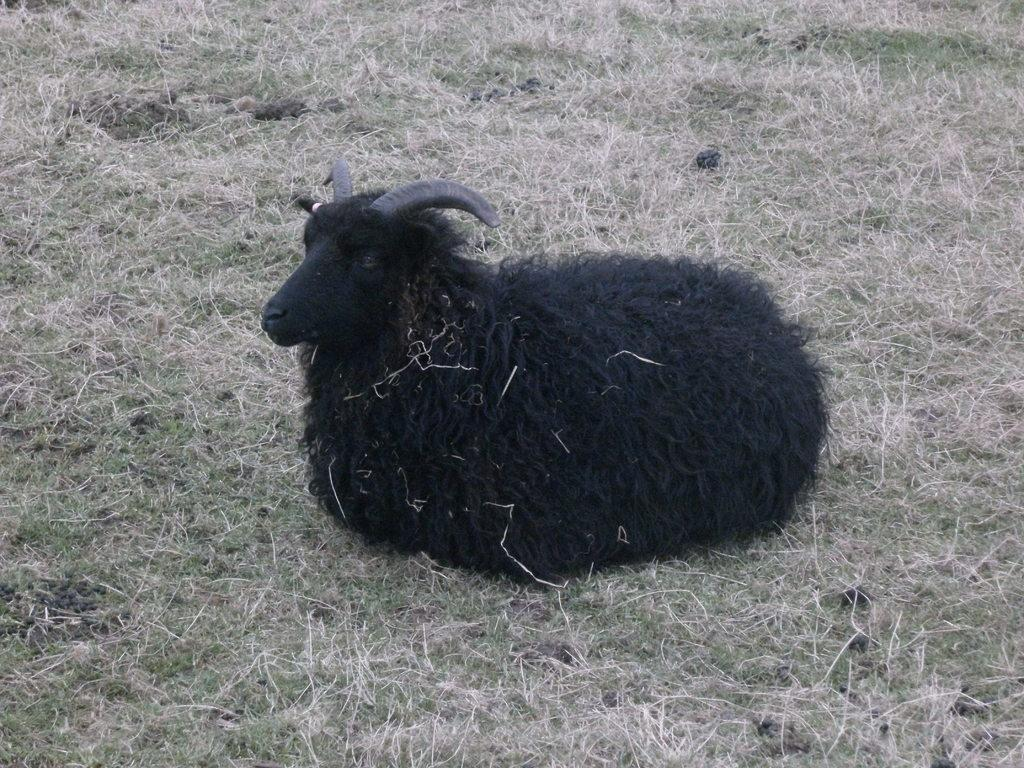What color is the sheep in the image? The sheep in the image is black. What is the sheep doing in the image? The sheep is sitting. What type of vegetation can be seen at the bottom of the image? There is grass visible at the bottom of the image. What type of chair is the sheep sitting on in the image? There is no chair present in the image; the sheep is sitting on the grass. What type of competition is the sheep participating in within the image? There is no competition present in the image; it simply shows a sitting black sheep. 